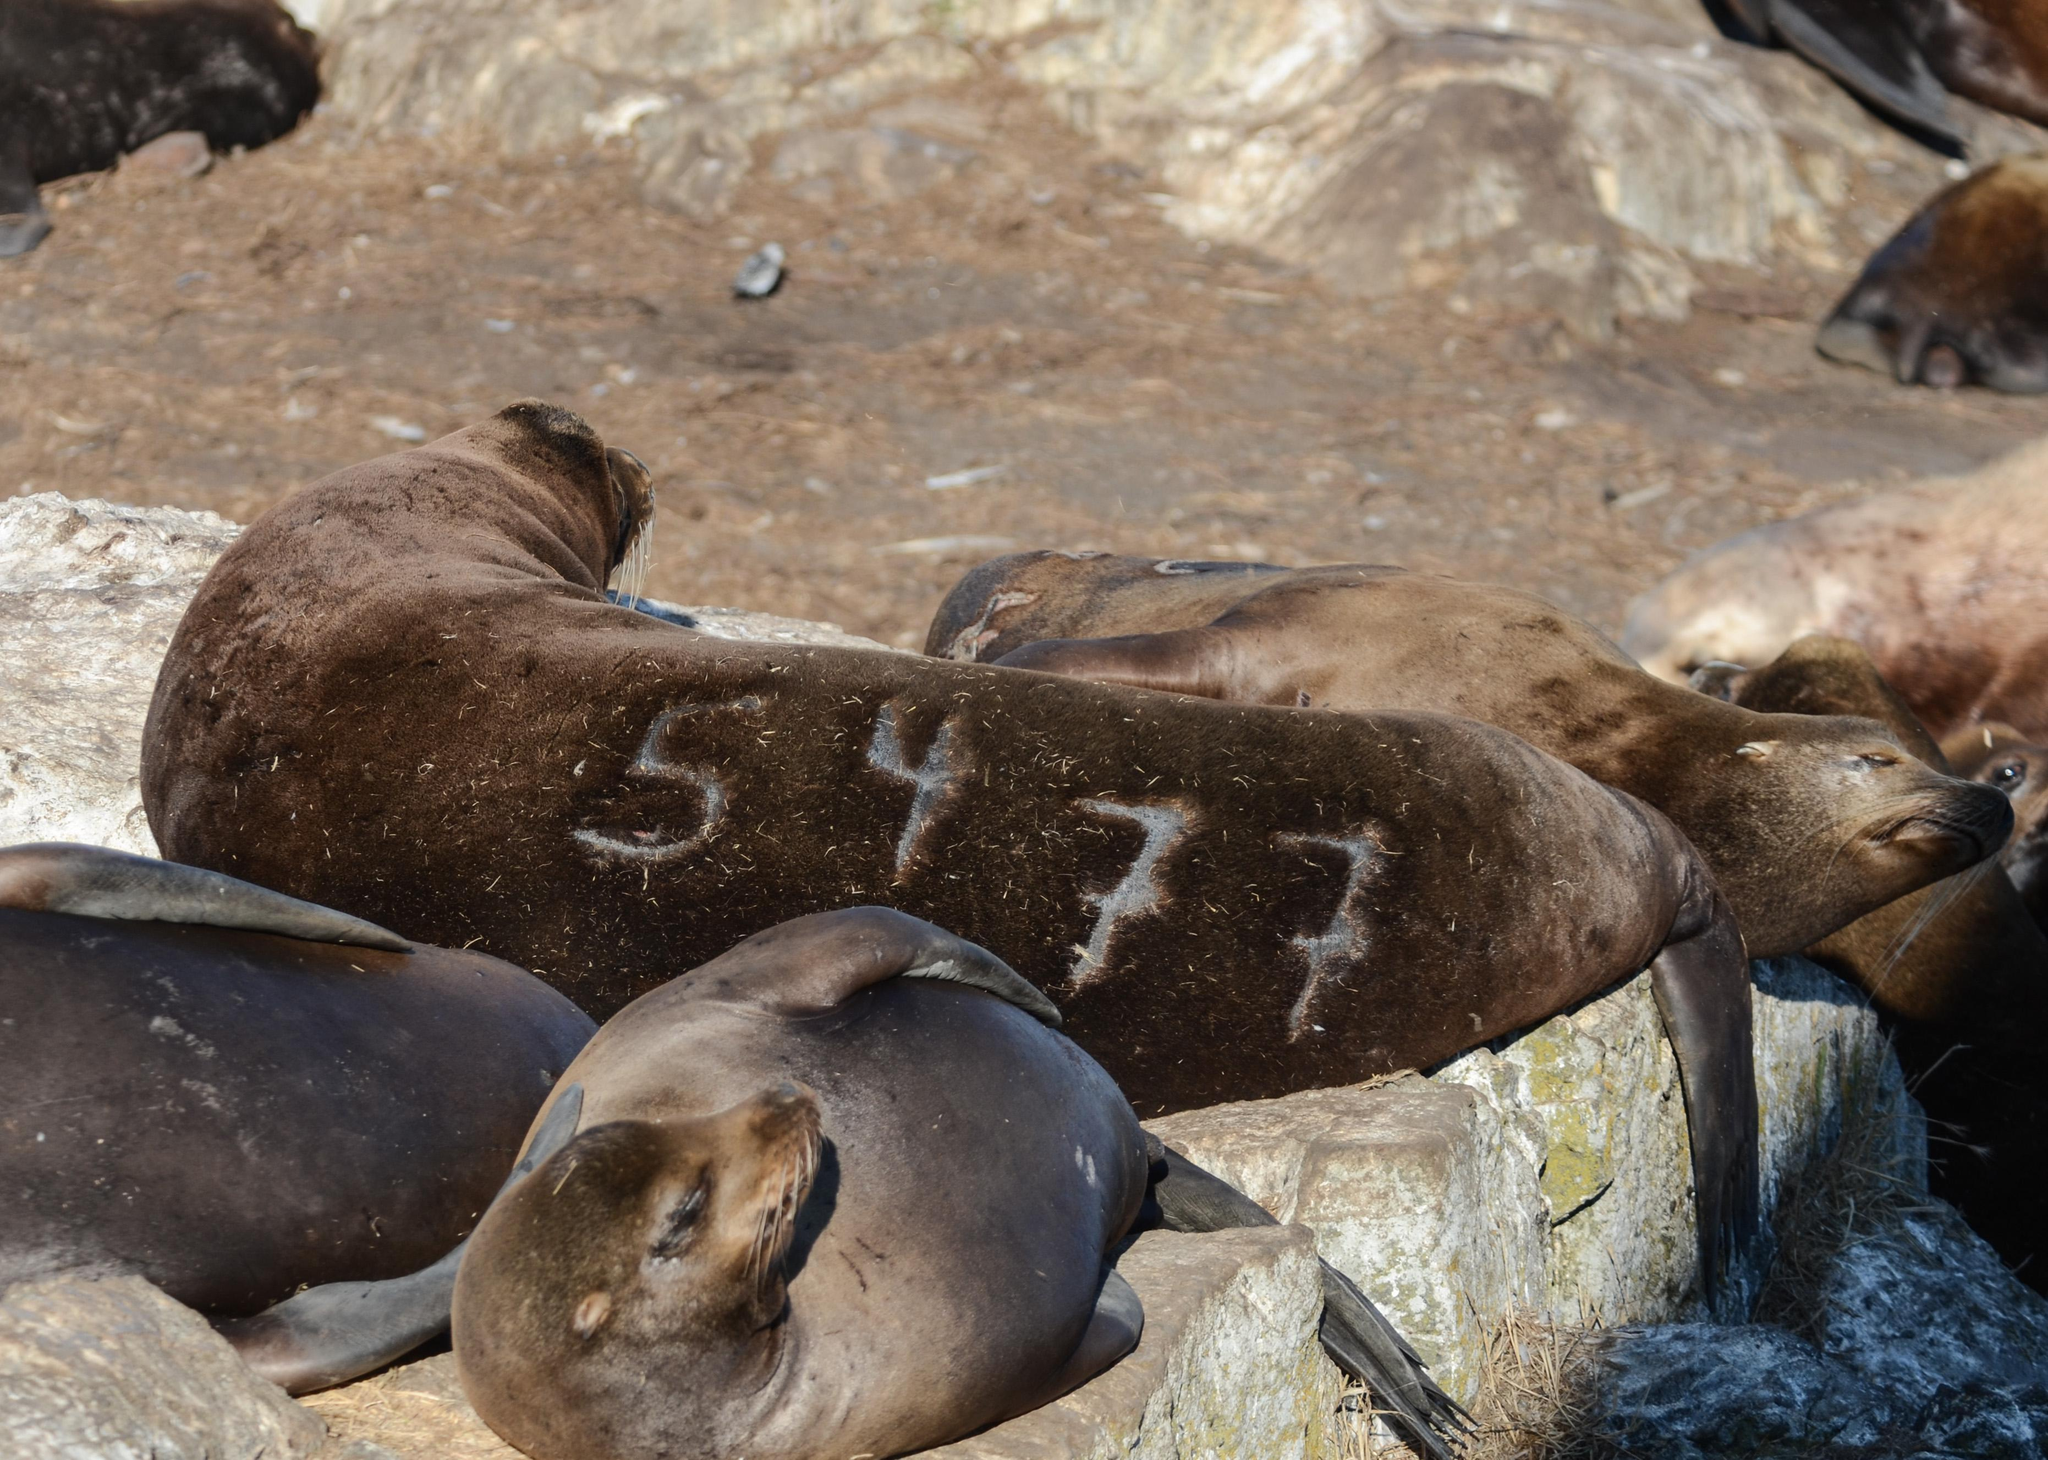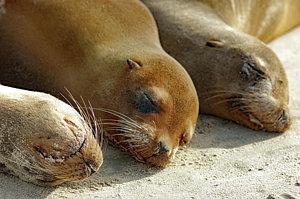The first image is the image on the left, the second image is the image on the right. For the images displayed, is the sentence "There are less than two sea mammals sunning in each of the images." factually correct? Answer yes or no. No. The first image is the image on the left, the second image is the image on the right. Assess this claim about the two images: "An image shows three seals sleeping side-by-side.". Correct or not? Answer yes or no. Yes. 